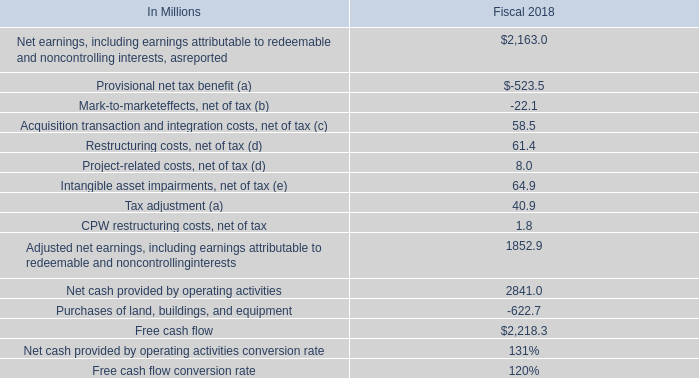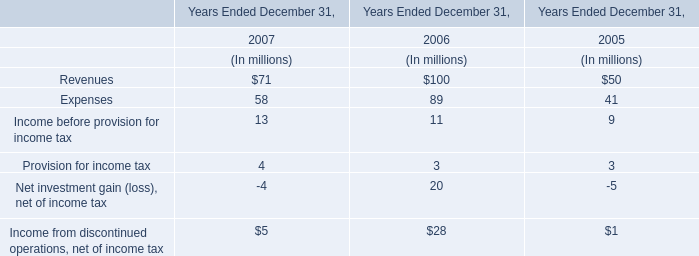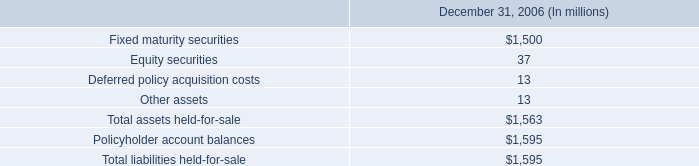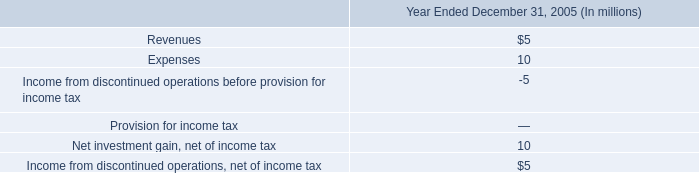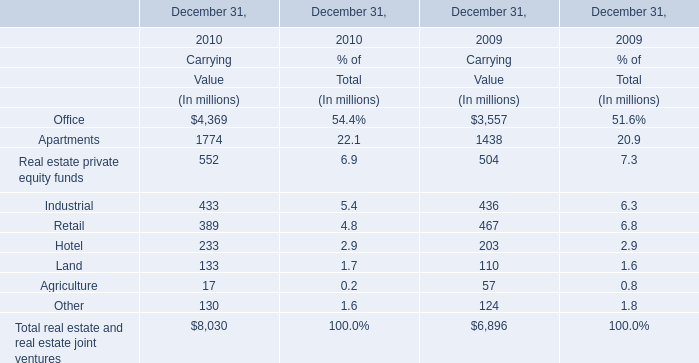What is the sum of Apartments of Carrying Value in 2010 and Total assets held-for-sale in 2006? (in million) 
Computations: (1774 + 1563)
Answer: 3337.0. 